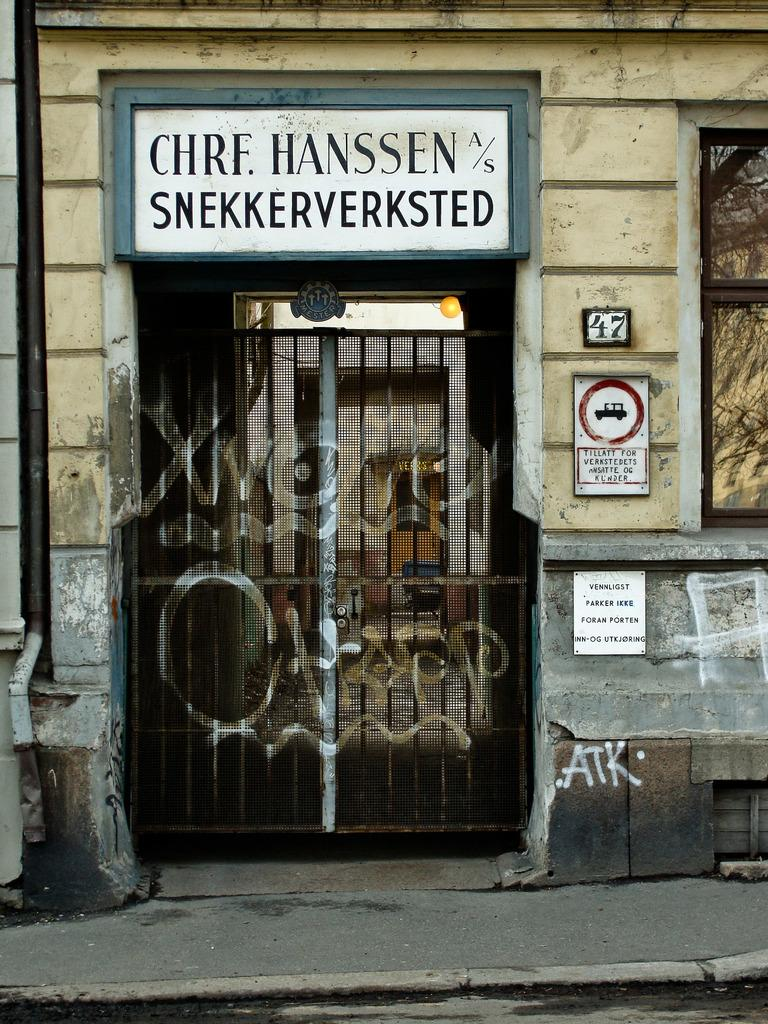What is the main structure visible in the image? There is a gate in the image. What is attached to the wall near the gate? There is a white color board attached to the wall in the image. What type of structure can be seen in the background? There is a building in the image. What is the color of the building? The building is in cream color. What is attached to the building in the image? There are papers attached to the building in the image. What type of plough is being used to learn in the image? There is no plough or learning activity present in the image. How many sacks are visible in the image? There are no sacks visible in the image. 